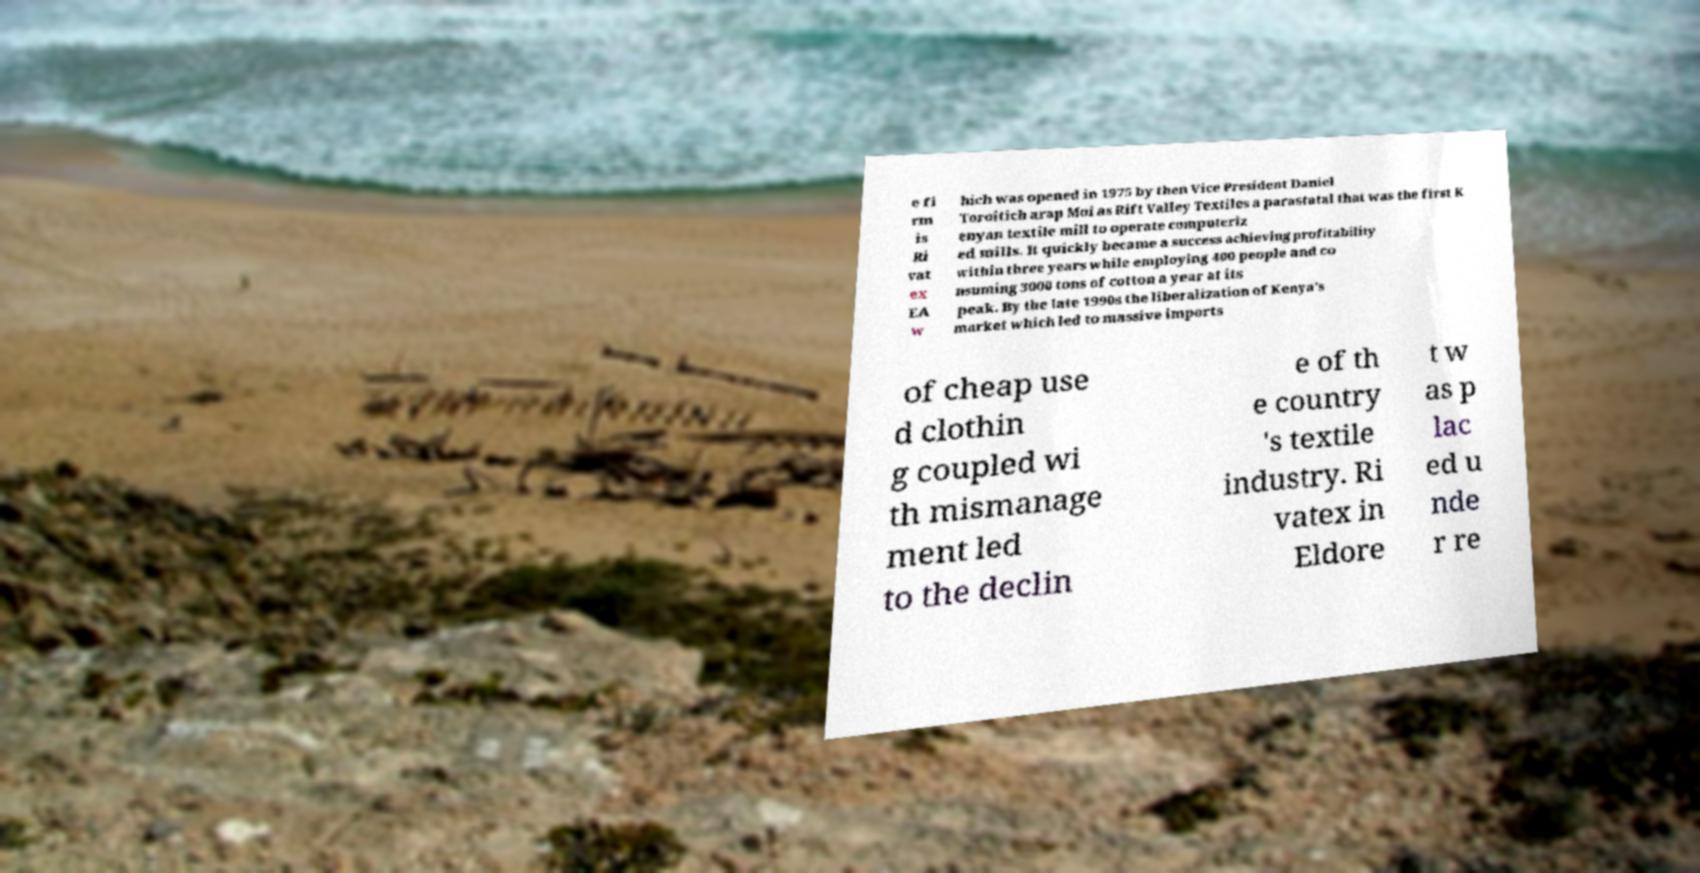There's text embedded in this image that I need extracted. Can you transcribe it verbatim? e fi rm is Ri vat ex EA w hich was opened in 1975 by then Vice President Daniel Toroitich arap Moi as Rift Valley Textiles a parastatal that was the first K enyan textile mill to operate computeriz ed mills. It quickly became a success achieving profitability within three years while employing 400 people and co nsuming 3000 tons of cotton a year at its peak. By the late 1990s the liberalization of Kenya's market which led to massive imports of cheap use d clothin g coupled wi th mismanage ment led to the declin e of th e country 's textile industry. Ri vatex in Eldore t w as p lac ed u nde r re 